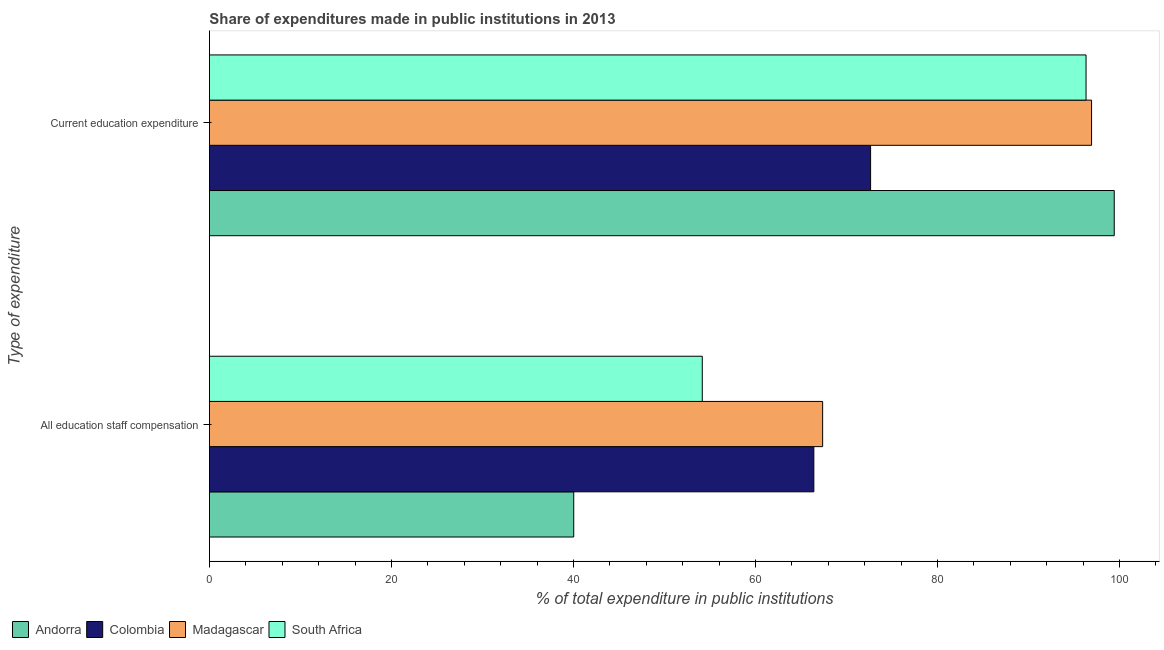How many different coloured bars are there?
Your answer should be very brief. 4. Are the number of bars per tick equal to the number of legend labels?
Make the answer very short. Yes. How many bars are there on the 1st tick from the top?
Your answer should be compact. 4. How many bars are there on the 1st tick from the bottom?
Ensure brevity in your answer.  4. What is the label of the 2nd group of bars from the top?
Your response must be concise. All education staff compensation. What is the expenditure in education in Colombia?
Your answer should be compact. 72.65. Across all countries, what is the maximum expenditure in education?
Make the answer very short. 99.42. Across all countries, what is the minimum expenditure in staff compensation?
Offer a terse response. 40.03. In which country was the expenditure in education maximum?
Provide a succinct answer. Andorra. In which country was the expenditure in staff compensation minimum?
Your answer should be very brief. Andorra. What is the total expenditure in education in the graph?
Make the answer very short. 365.31. What is the difference between the expenditure in staff compensation in Colombia and that in South Africa?
Your answer should be very brief. 12.26. What is the difference between the expenditure in education in Colombia and the expenditure in staff compensation in Andorra?
Make the answer very short. 32.62. What is the average expenditure in staff compensation per country?
Your answer should be very brief. 56.99. What is the difference between the expenditure in staff compensation and expenditure in education in South Africa?
Your response must be concise. -42.17. What is the ratio of the expenditure in education in Madagascar to that in South Africa?
Your response must be concise. 1.01. In how many countries, is the expenditure in staff compensation greater than the average expenditure in staff compensation taken over all countries?
Your response must be concise. 2. What does the 1st bar from the top in All education staff compensation represents?
Make the answer very short. South Africa. What does the 1st bar from the bottom in All education staff compensation represents?
Give a very brief answer. Andorra. How many bars are there?
Your response must be concise. 8. What is the difference between two consecutive major ticks on the X-axis?
Give a very brief answer. 20. Are the values on the major ticks of X-axis written in scientific E-notation?
Your response must be concise. No. Does the graph contain any zero values?
Make the answer very short. No. Where does the legend appear in the graph?
Provide a short and direct response. Bottom left. How are the legend labels stacked?
Make the answer very short. Horizontal. What is the title of the graph?
Ensure brevity in your answer.  Share of expenditures made in public institutions in 2013. What is the label or title of the X-axis?
Offer a very short reply. % of total expenditure in public institutions. What is the label or title of the Y-axis?
Keep it short and to the point. Type of expenditure. What is the % of total expenditure in public institutions of Andorra in All education staff compensation?
Your response must be concise. 40.03. What is the % of total expenditure in public institutions of Colombia in All education staff compensation?
Offer a very short reply. 66.41. What is the % of total expenditure in public institutions of Madagascar in All education staff compensation?
Provide a short and direct response. 67.38. What is the % of total expenditure in public institutions in South Africa in All education staff compensation?
Offer a very short reply. 54.15. What is the % of total expenditure in public institutions of Andorra in Current education expenditure?
Ensure brevity in your answer.  99.42. What is the % of total expenditure in public institutions in Colombia in Current education expenditure?
Give a very brief answer. 72.65. What is the % of total expenditure in public institutions of Madagascar in Current education expenditure?
Your answer should be compact. 96.92. What is the % of total expenditure in public institutions in South Africa in Current education expenditure?
Your answer should be very brief. 96.32. Across all Type of expenditure, what is the maximum % of total expenditure in public institutions in Andorra?
Provide a succinct answer. 99.42. Across all Type of expenditure, what is the maximum % of total expenditure in public institutions in Colombia?
Offer a very short reply. 72.65. Across all Type of expenditure, what is the maximum % of total expenditure in public institutions of Madagascar?
Your answer should be very brief. 96.92. Across all Type of expenditure, what is the maximum % of total expenditure in public institutions of South Africa?
Make the answer very short. 96.32. Across all Type of expenditure, what is the minimum % of total expenditure in public institutions of Andorra?
Provide a short and direct response. 40.03. Across all Type of expenditure, what is the minimum % of total expenditure in public institutions in Colombia?
Make the answer very short. 66.41. Across all Type of expenditure, what is the minimum % of total expenditure in public institutions in Madagascar?
Your response must be concise. 67.38. Across all Type of expenditure, what is the minimum % of total expenditure in public institutions in South Africa?
Your answer should be compact. 54.15. What is the total % of total expenditure in public institutions of Andorra in the graph?
Your answer should be very brief. 139.45. What is the total % of total expenditure in public institutions in Colombia in the graph?
Your answer should be compact. 139.06. What is the total % of total expenditure in public institutions of Madagascar in the graph?
Your answer should be compact. 164.3. What is the total % of total expenditure in public institutions in South Africa in the graph?
Make the answer very short. 150.47. What is the difference between the % of total expenditure in public institutions of Andorra in All education staff compensation and that in Current education expenditure?
Provide a succinct answer. -59.39. What is the difference between the % of total expenditure in public institutions of Colombia in All education staff compensation and that in Current education expenditure?
Make the answer very short. -6.24. What is the difference between the % of total expenditure in public institutions of Madagascar in All education staff compensation and that in Current education expenditure?
Give a very brief answer. -29.55. What is the difference between the % of total expenditure in public institutions of South Africa in All education staff compensation and that in Current education expenditure?
Keep it short and to the point. -42.17. What is the difference between the % of total expenditure in public institutions in Andorra in All education staff compensation and the % of total expenditure in public institutions in Colombia in Current education expenditure?
Give a very brief answer. -32.62. What is the difference between the % of total expenditure in public institutions of Andorra in All education staff compensation and the % of total expenditure in public institutions of Madagascar in Current education expenditure?
Offer a terse response. -56.9. What is the difference between the % of total expenditure in public institutions of Andorra in All education staff compensation and the % of total expenditure in public institutions of South Africa in Current education expenditure?
Keep it short and to the point. -56.29. What is the difference between the % of total expenditure in public institutions in Colombia in All education staff compensation and the % of total expenditure in public institutions in Madagascar in Current education expenditure?
Give a very brief answer. -30.51. What is the difference between the % of total expenditure in public institutions in Colombia in All education staff compensation and the % of total expenditure in public institutions in South Africa in Current education expenditure?
Provide a succinct answer. -29.91. What is the difference between the % of total expenditure in public institutions of Madagascar in All education staff compensation and the % of total expenditure in public institutions of South Africa in Current education expenditure?
Your answer should be very brief. -28.94. What is the average % of total expenditure in public institutions of Andorra per Type of expenditure?
Your answer should be very brief. 69.72. What is the average % of total expenditure in public institutions in Colombia per Type of expenditure?
Give a very brief answer. 69.53. What is the average % of total expenditure in public institutions in Madagascar per Type of expenditure?
Your answer should be compact. 82.15. What is the average % of total expenditure in public institutions of South Africa per Type of expenditure?
Keep it short and to the point. 75.24. What is the difference between the % of total expenditure in public institutions of Andorra and % of total expenditure in public institutions of Colombia in All education staff compensation?
Give a very brief answer. -26.38. What is the difference between the % of total expenditure in public institutions in Andorra and % of total expenditure in public institutions in Madagascar in All education staff compensation?
Your answer should be very brief. -27.35. What is the difference between the % of total expenditure in public institutions of Andorra and % of total expenditure in public institutions of South Africa in All education staff compensation?
Your answer should be very brief. -14.12. What is the difference between the % of total expenditure in public institutions of Colombia and % of total expenditure in public institutions of Madagascar in All education staff compensation?
Make the answer very short. -0.97. What is the difference between the % of total expenditure in public institutions of Colombia and % of total expenditure in public institutions of South Africa in All education staff compensation?
Your answer should be compact. 12.26. What is the difference between the % of total expenditure in public institutions of Madagascar and % of total expenditure in public institutions of South Africa in All education staff compensation?
Provide a short and direct response. 13.22. What is the difference between the % of total expenditure in public institutions of Andorra and % of total expenditure in public institutions of Colombia in Current education expenditure?
Keep it short and to the point. 26.77. What is the difference between the % of total expenditure in public institutions in Andorra and % of total expenditure in public institutions in Madagascar in Current education expenditure?
Your answer should be compact. 2.49. What is the difference between the % of total expenditure in public institutions in Andorra and % of total expenditure in public institutions in South Africa in Current education expenditure?
Offer a very short reply. 3.1. What is the difference between the % of total expenditure in public institutions in Colombia and % of total expenditure in public institutions in Madagascar in Current education expenditure?
Your response must be concise. -24.28. What is the difference between the % of total expenditure in public institutions of Colombia and % of total expenditure in public institutions of South Africa in Current education expenditure?
Provide a short and direct response. -23.67. What is the difference between the % of total expenditure in public institutions of Madagascar and % of total expenditure in public institutions of South Africa in Current education expenditure?
Ensure brevity in your answer.  0.61. What is the ratio of the % of total expenditure in public institutions of Andorra in All education staff compensation to that in Current education expenditure?
Keep it short and to the point. 0.4. What is the ratio of the % of total expenditure in public institutions in Colombia in All education staff compensation to that in Current education expenditure?
Offer a terse response. 0.91. What is the ratio of the % of total expenditure in public institutions in Madagascar in All education staff compensation to that in Current education expenditure?
Offer a very short reply. 0.7. What is the ratio of the % of total expenditure in public institutions of South Africa in All education staff compensation to that in Current education expenditure?
Ensure brevity in your answer.  0.56. What is the difference between the highest and the second highest % of total expenditure in public institutions in Andorra?
Keep it short and to the point. 59.39. What is the difference between the highest and the second highest % of total expenditure in public institutions of Colombia?
Your answer should be compact. 6.24. What is the difference between the highest and the second highest % of total expenditure in public institutions of Madagascar?
Your answer should be very brief. 29.55. What is the difference between the highest and the second highest % of total expenditure in public institutions of South Africa?
Give a very brief answer. 42.17. What is the difference between the highest and the lowest % of total expenditure in public institutions of Andorra?
Provide a short and direct response. 59.39. What is the difference between the highest and the lowest % of total expenditure in public institutions in Colombia?
Your answer should be compact. 6.24. What is the difference between the highest and the lowest % of total expenditure in public institutions in Madagascar?
Offer a terse response. 29.55. What is the difference between the highest and the lowest % of total expenditure in public institutions of South Africa?
Give a very brief answer. 42.17. 